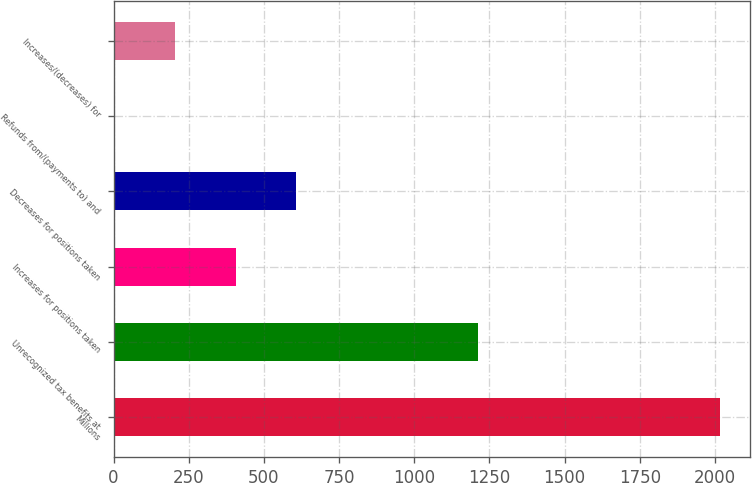<chart> <loc_0><loc_0><loc_500><loc_500><bar_chart><fcel>Millions<fcel>Unrecognized tax benefits at<fcel>Increases for positions taken<fcel>Decreases for positions taken<fcel>Refunds from/(payments to) and<fcel>Increases/(decreases) for<nl><fcel>2016<fcel>1211.2<fcel>406.4<fcel>607.6<fcel>4<fcel>205.2<nl></chart> 